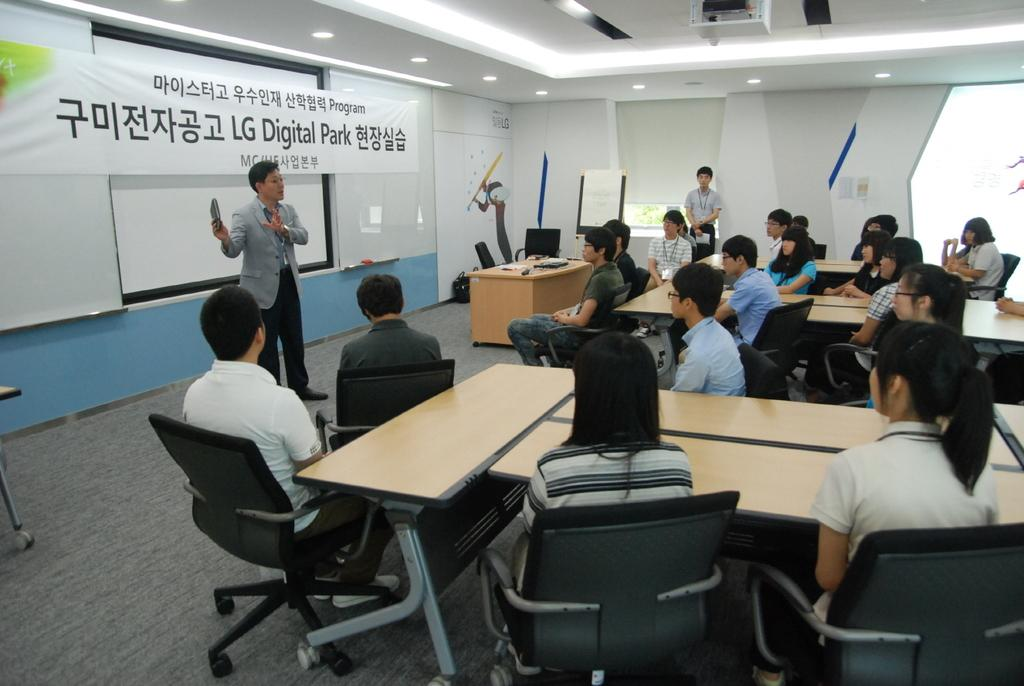What is the person in the image wearing? The person in the image is wearing a suit. What is the person doing in the image? The person is standing and speaking. How many people are in the image? There is a group of people in the image. Where is the person in relation to the group? The person is in front of the group. What can be seen on the banner in the image? The banner has "LG Digital Park" written on it. Can you see any sand or roots in the image? No, there is no sand or roots present in the image. How many sheep are visible in the image? There are no sheep present in the image. 